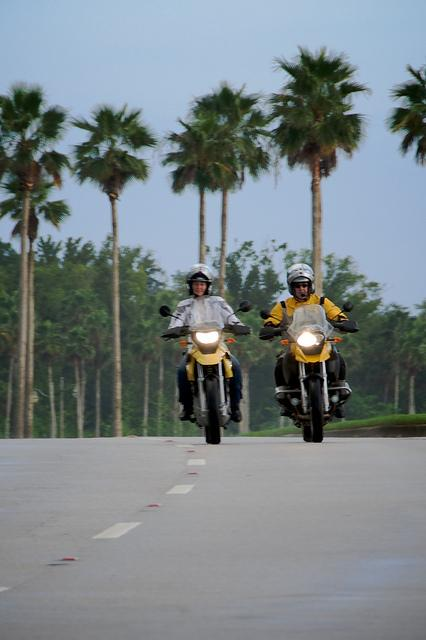What type of vehicle are the men riding? motorcycle 